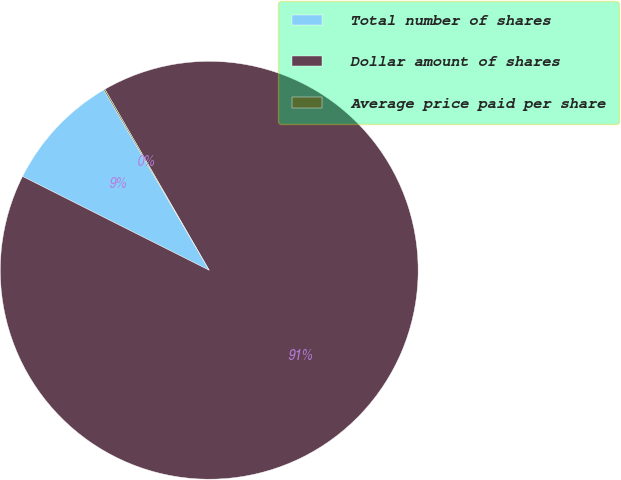Convert chart. <chart><loc_0><loc_0><loc_500><loc_500><pie_chart><fcel>Total number of shares<fcel>Dollar amount of shares<fcel>Average price paid per share<nl><fcel>9.16%<fcel>90.73%<fcel>0.1%<nl></chart> 